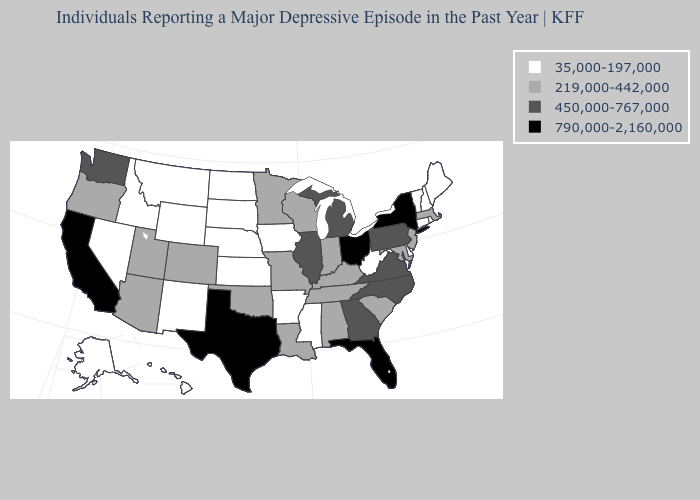Name the states that have a value in the range 219,000-442,000?
Short answer required. Alabama, Arizona, Colorado, Indiana, Kentucky, Louisiana, Maryland, Massachusetts, Minnesota, Missouri, New Jersey, Oklahoma, Oregon, South Carolina, Tennessee, Utah, Wisconsin. Does Oklahoma have the same value as Massachusetts?
Keep it brief. Yes. What is the highest value in the USA?
Quick response, please. 790,000-2,160,000. Name the states that have a value in the range 450,000-767,000?
Give a very brief answer. Georgia, Illinois, Michigan, North Carolina, Pennsylvania, Virginia, Washington. What is the value of Oklahoma?
Write a very short answer. 219,000-442,000. Among the states that border Mississippi , does Tennessee have the lowest value?
Concise answer only. No. Name the states that have a value in the range 790,000-2,160,000?
Write a very short answer. California, Florida, New York, Ohio, Texas. Name the states that have a value in the range 219,000-442,000?
Concise answer only. Alabama, Arizona, Colorado, Indiana, Kentucky, Louisiana, Maryland, Massachusetts, Minnesota, Missouri, New Jersey, Oklahoma, Oregon, South Carolina, Tennessee, Utah, Wisconsin. What is the value of West Virginia?
Short answer required. 35,000-197,000. Among the states that border New Jersey , does Pennsylvania have the highest value?
Concise answer only. No. What is the value of North Carolina?
Keep it brief. 450,000-767,000. Does Florida have the highest value in the South?
Quick response, please. Yes. What is the value of Utah?
Give a very brief answer. 219,000-442,000. What is the value of Wisconsin?
Answer briefly. 219,000-442,000. Name the states that have a value in the range 450,000-767,000?
Quick response, please. Georgia, Illinois, Michigan, North Carolina, Pennsylvania, Virginia, Washington. 